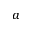Convert formula to latex. <formula><loc_0><loc_0><loc_500><loc_500>^ { a }</formula> 